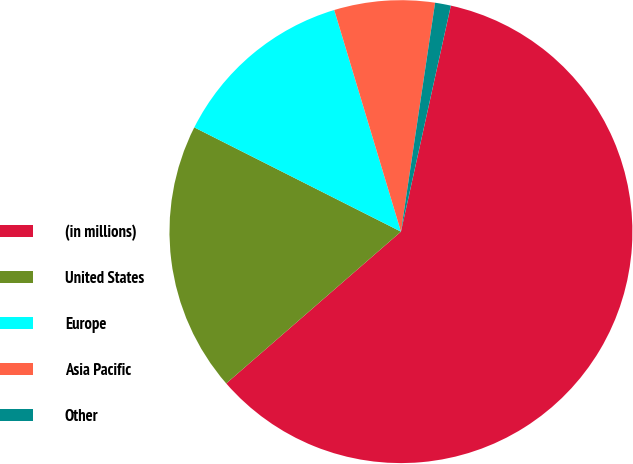<chart> <loc_0><loc_0><loc_500><loc_500><pie_chart><fcel>(in millions)<fcel>United States<fcel>Europe<fcel>Asia Pacific<fcel>Other<nl><fcel>60.15%<fcel>18.82%<fcel>12.91%<fcel>7.01%<fcel>1.1%<nl></chart> 